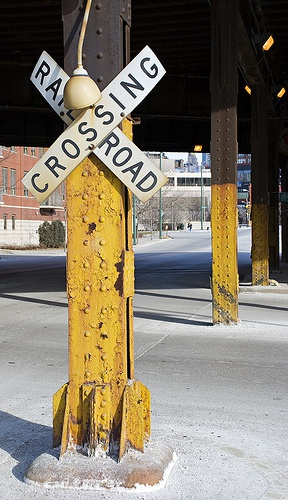Describe the objects in this image and their specific colors. I can see various objects in this image with different colors. 